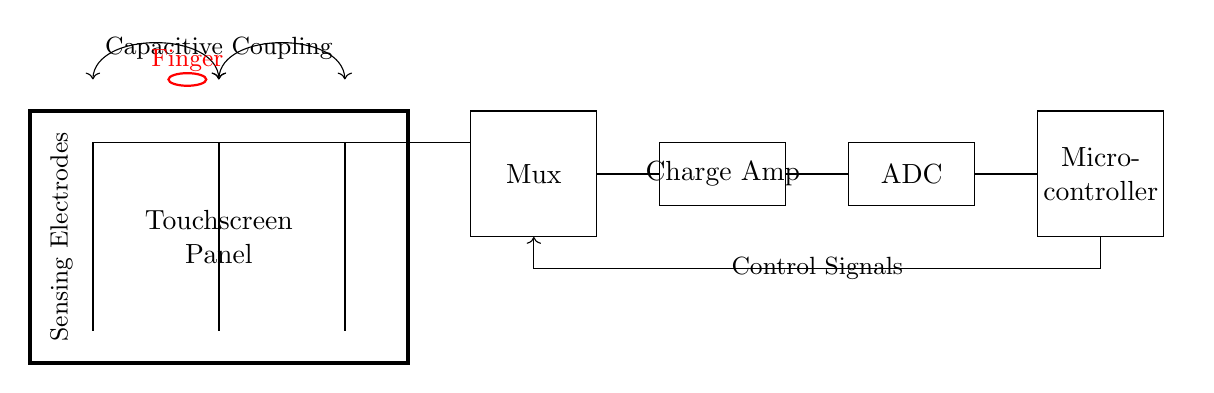What are the components present in the circuit? The circuit consists of a touchscreen panel, sensing electrodes, a multiplexer, a charge amplifier, an ADC, and a microcontroller. Each component is labeled clearly in the circuit diagram.
Answer: touchscreen panel, sensing electrodes, multiplexer, charge amplifier, ADC, microcontroller What is the function of the multiplexer in this circuit? The multiplexer selects one of the multiple signals from the sensing electrodes and sends it to the charge amplifier, enabling the processing of touch input effectively. This is indicated by the connections from the sensing electrodes to the multiplexer.
Answer: signal selection How many sensing electrodes are present? There are three sensing electrodes. This is shown in the circuit where three vertical lines are drawn to represent the electrodes.
Answer: three What type of coupling is used in the touchscreen sensing circuit? The type of coupling used is capacitive coupling. The diagram visually indicates this with the arrows labeled "Capacitive Coupling" connecting the sensing electrodes.
Answer: capacitive coupling Which component receives control signals in the circuit? The microcontroller receives control signals as shown by the arrow connecting it to the multiplexer. The direction of the arrow indicates the flow of these control signals.
Answer: microcontroller What happens when a finger touches the panel? When a finger touches the panel, the capacitance changes at the sensing electrodes, allowing the signals to be processed through the multiplexer, to the charge amplifier, and eventually to the ADC for interpretation. This is denoted by the red ellipse labeled "Finger."
Answer: capacitance change What role does the ADC play in the circuit? The ADC (Analog to Digital Converter) converts the analog signals outputted by the charge amplifier into digital signals for further processing by the microcontroller, facilitating interaction with the touchscreen. This is illustrated by the connection from the charge amplifier to the ADC.
Answer: analog to digital conversion 